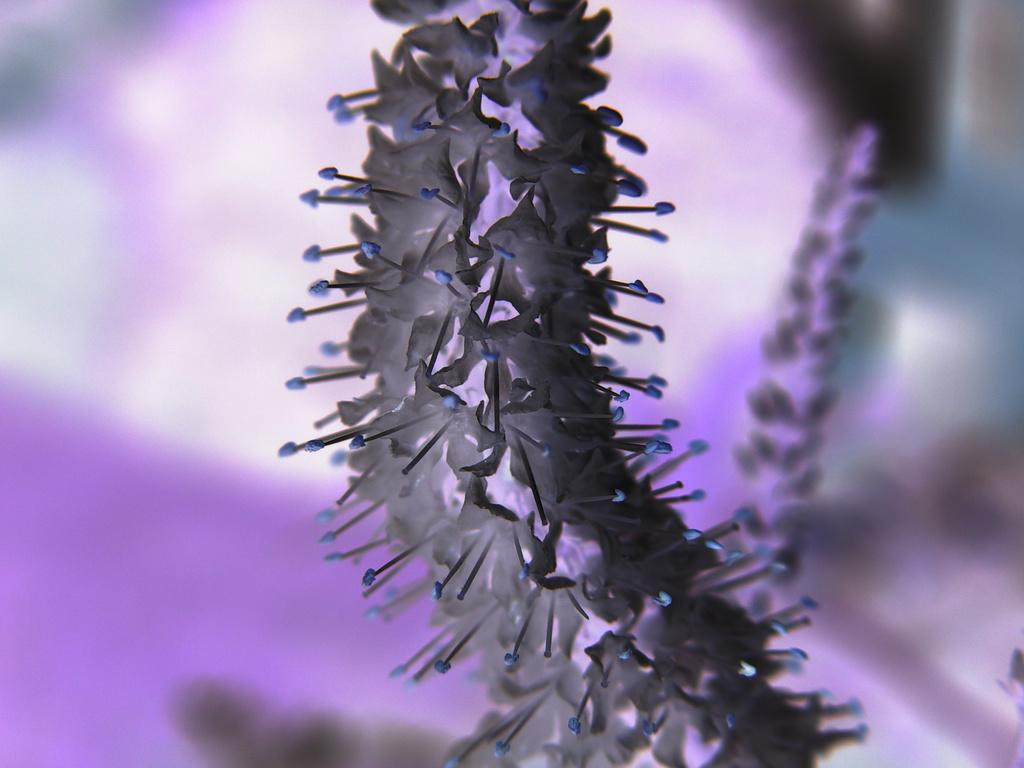What type of editing has been applied to the image? The image is edited, but the specific type of editing is not mentioned in the facts. What is the main subject of the image? The image consists of flowers. How is the background of the image treated? The background of the image is blurred. What month is depicted in the image? The facts do not mention any specific month or season, so it is not possible to determine the month from the image. 